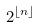<formula> <loc_0><loc_0><loc_500><loc_500>2 ^ { \lfloor n \rfloor }</formula> 